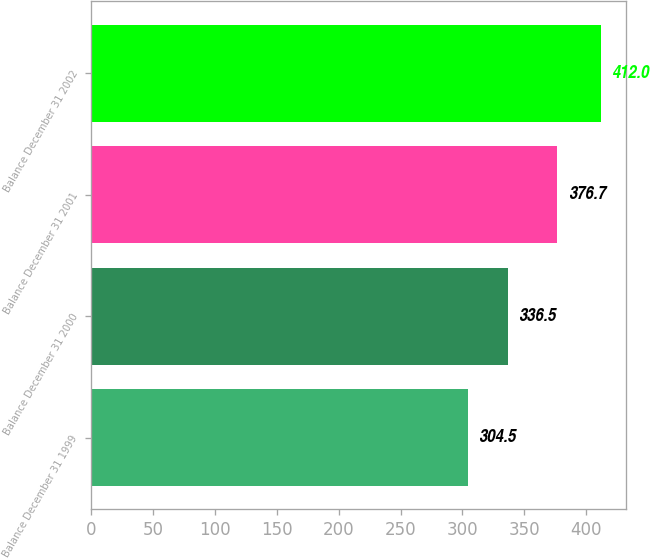Convert chart. <chart><loc_0><loc_0><loc_500><loc_500><bar_chart><fcel>Balance December 31 1999<fcel>Balance December 31 2000<fcel>Balance December 31 2001<fcel>Balance December 31 2002<nl><fcel>304.5<fcel>336.5<fcel>376.7<fcel>412<nl></chart> 